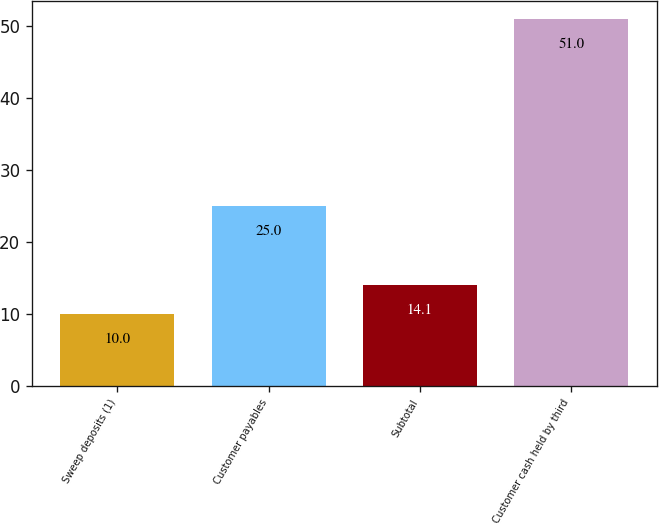<chart> <loc_0><loc_0><loc_500><loc_500><bar_chart><fcel>Sweep deposits (1)<fcel>Customer payables<fcel>Subtotal<fcel>Customer cash held by third<nl><fcel>10<fcel>25<fcel>14.1<fcel>51<nl></chart> 